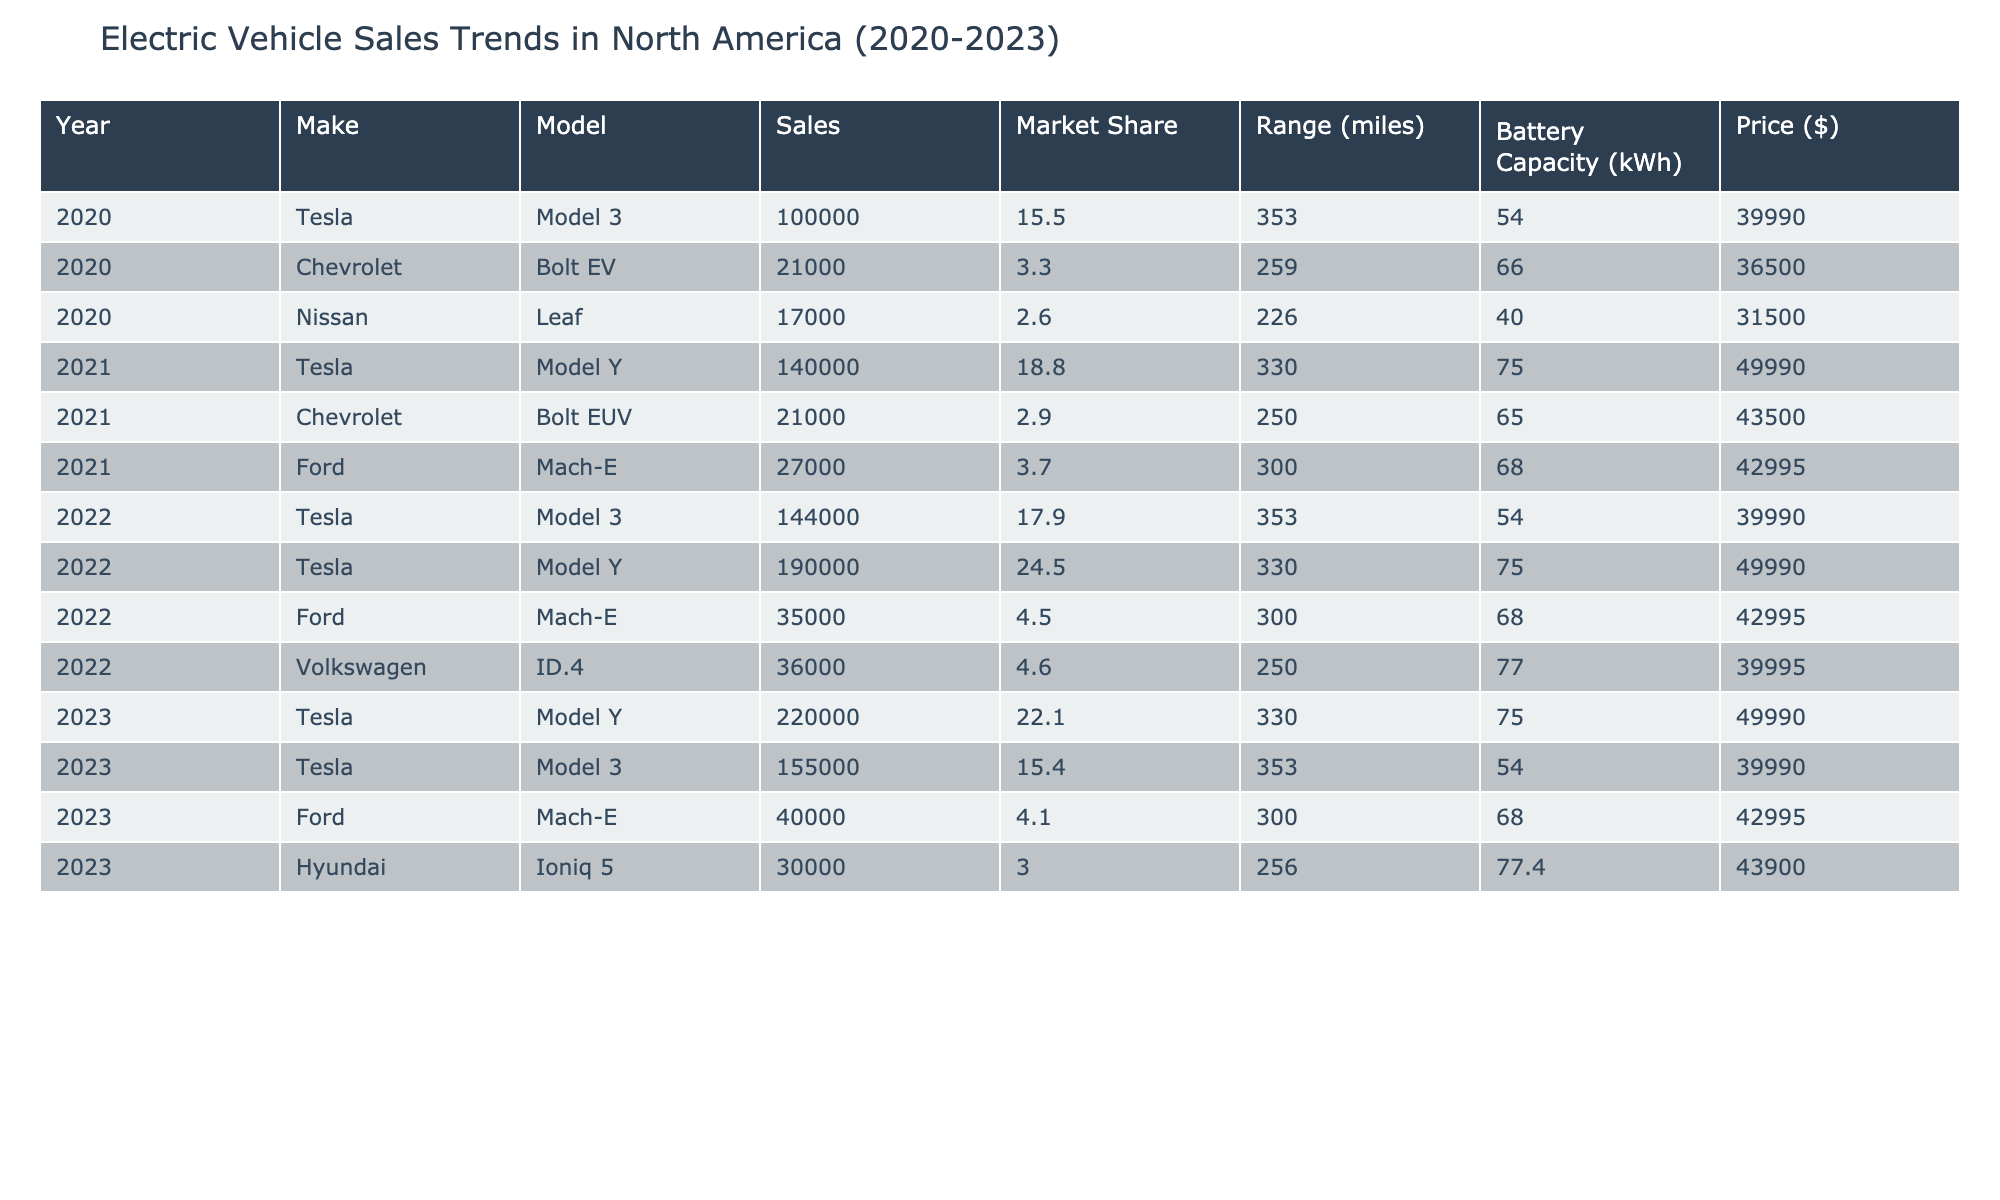What was the total number of Tesla Model 3 sales from 2020 to 2023? To determine the total sales of Tesla Model 3, we need to sum the sales figures for the years it was sold: 100,000 in 2020, 144,000 in 2022, and 155,000 in 2023. The sum is 100,000 + 144,000 + 155,000 = 399,000.
Answer: 399,000 Which brand had the highest market share in 2022? In 2022, the market shares listed in the table are: Tesla Model 3 - 17.9%, Tesla Model Y - 24.5%, Ford Mach-E - 4.5%, and Volkswagen ID.4 - 4.6%. The highest market share is from the Tesla Model Y at 24.5%.
Answer: Tesla Model Y Did the Nissan Leaf have any sales in 2021? The table shows data for Nissan Leaf only for the year 2020 with sales of 17,000, and there is no entry for 2021. Therefore, the Nissan Leaf did not have any sales in 2021.
Answer: No What is the average price of Ford vehicles sold from 2020 to 2023? The Ford vehicles listed are Mach-E with price 42,995 in 2021, 42,995 in 2022, and 42,995 in 2023. To find the average, sum the prices (42,995 + 42,995 + 42,995) and divide by the number of years (3), resulting in an average price of 42,995.
Answer: 42,995 Which vehicle had the longest range in 2023? In 2023, the range values for the vehicles listed are: Tesla Model Y - 330 miles, Tesla Model 3 - 353 miles, Ford Mach-E - 300 miles, and Hyundai Ioniq 5 - 256 miles. The longest range is from the Tesla Model 3 at 353 miles.
Answer: Tesla Model 3 